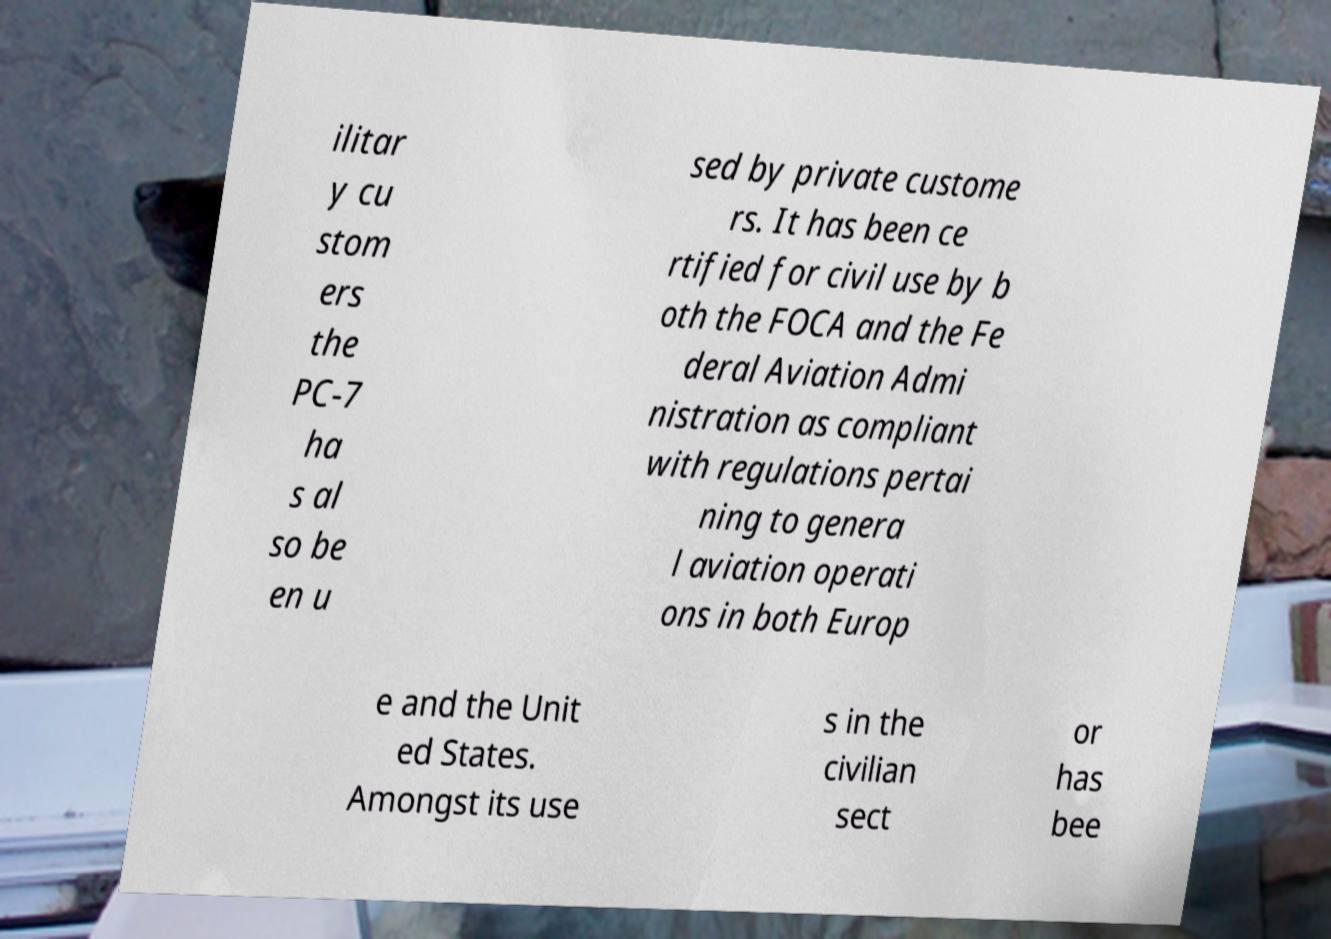Please identify and transcribe the text found in this image. ilitar y cu stom ers the PC-7 ha s al so be en u sed by private custome rs. It has been ce rtified for civil use by b oth the FOCA and the Fe deral Aviation Admi nistration as compliant with regulations pertai ning to genera l aviation operati ons in both Europ e and the Unit ed States. Amongst its use s in the civilian sect or has bee 